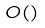Convert formula to latex. <formula><loc_0><loc_0><loc_500><loc_500>O ( )</formula> 